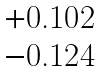<formula> <loc_0><loc_0><loc_500><loc_500>\begin{matrix} + 0 . 1 0 2 \\ - 0 . 1 2 4 \end{matrix}</formula> 